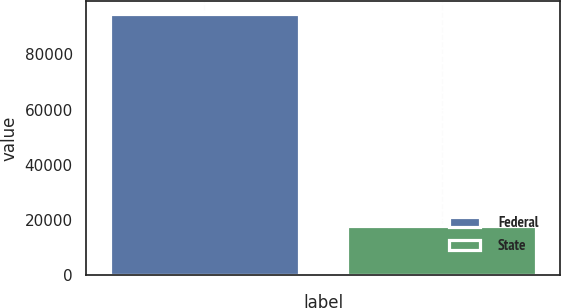Convert chart to OTSL. <chart><loc_0><loc_0><loc_500><loc_500><bar_chart><fcel>Federal<fcel>State<nl><fcel>94626<fcel>17623<nl></chart> 